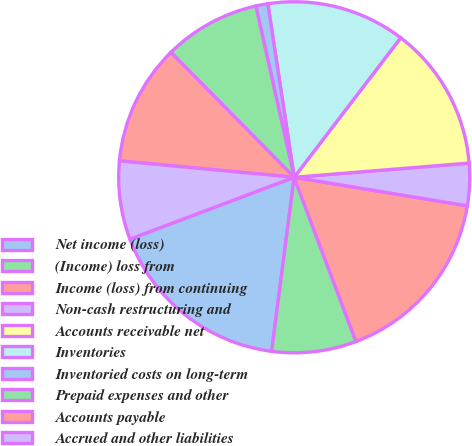Convert chart to OTSL. <chart><loc_0><loc_0><loc_500><loc_500><pie_chart><fcel>Net income (loss)<fcel>(Income) loss from<fcel>Income (loss) from continuing<fcel>Non-cash restructuring and<fcel>Accounts receivable net<fcel>Inventories<fcel>Inventoried costs on long-term<fcel>Prepaid expenses and other<fcel>Accounts payable<fcel>Accrued and other liabilities<nl><fcel>17.22%<fcel>7.78%<fcel>16.67%<fcel>3.89%<fcel>13.33%<fcel>12.78%<fcel>1.11%<fcel>8.89%<fcel>11.11%<fcel>7.22%<nl></chart> 